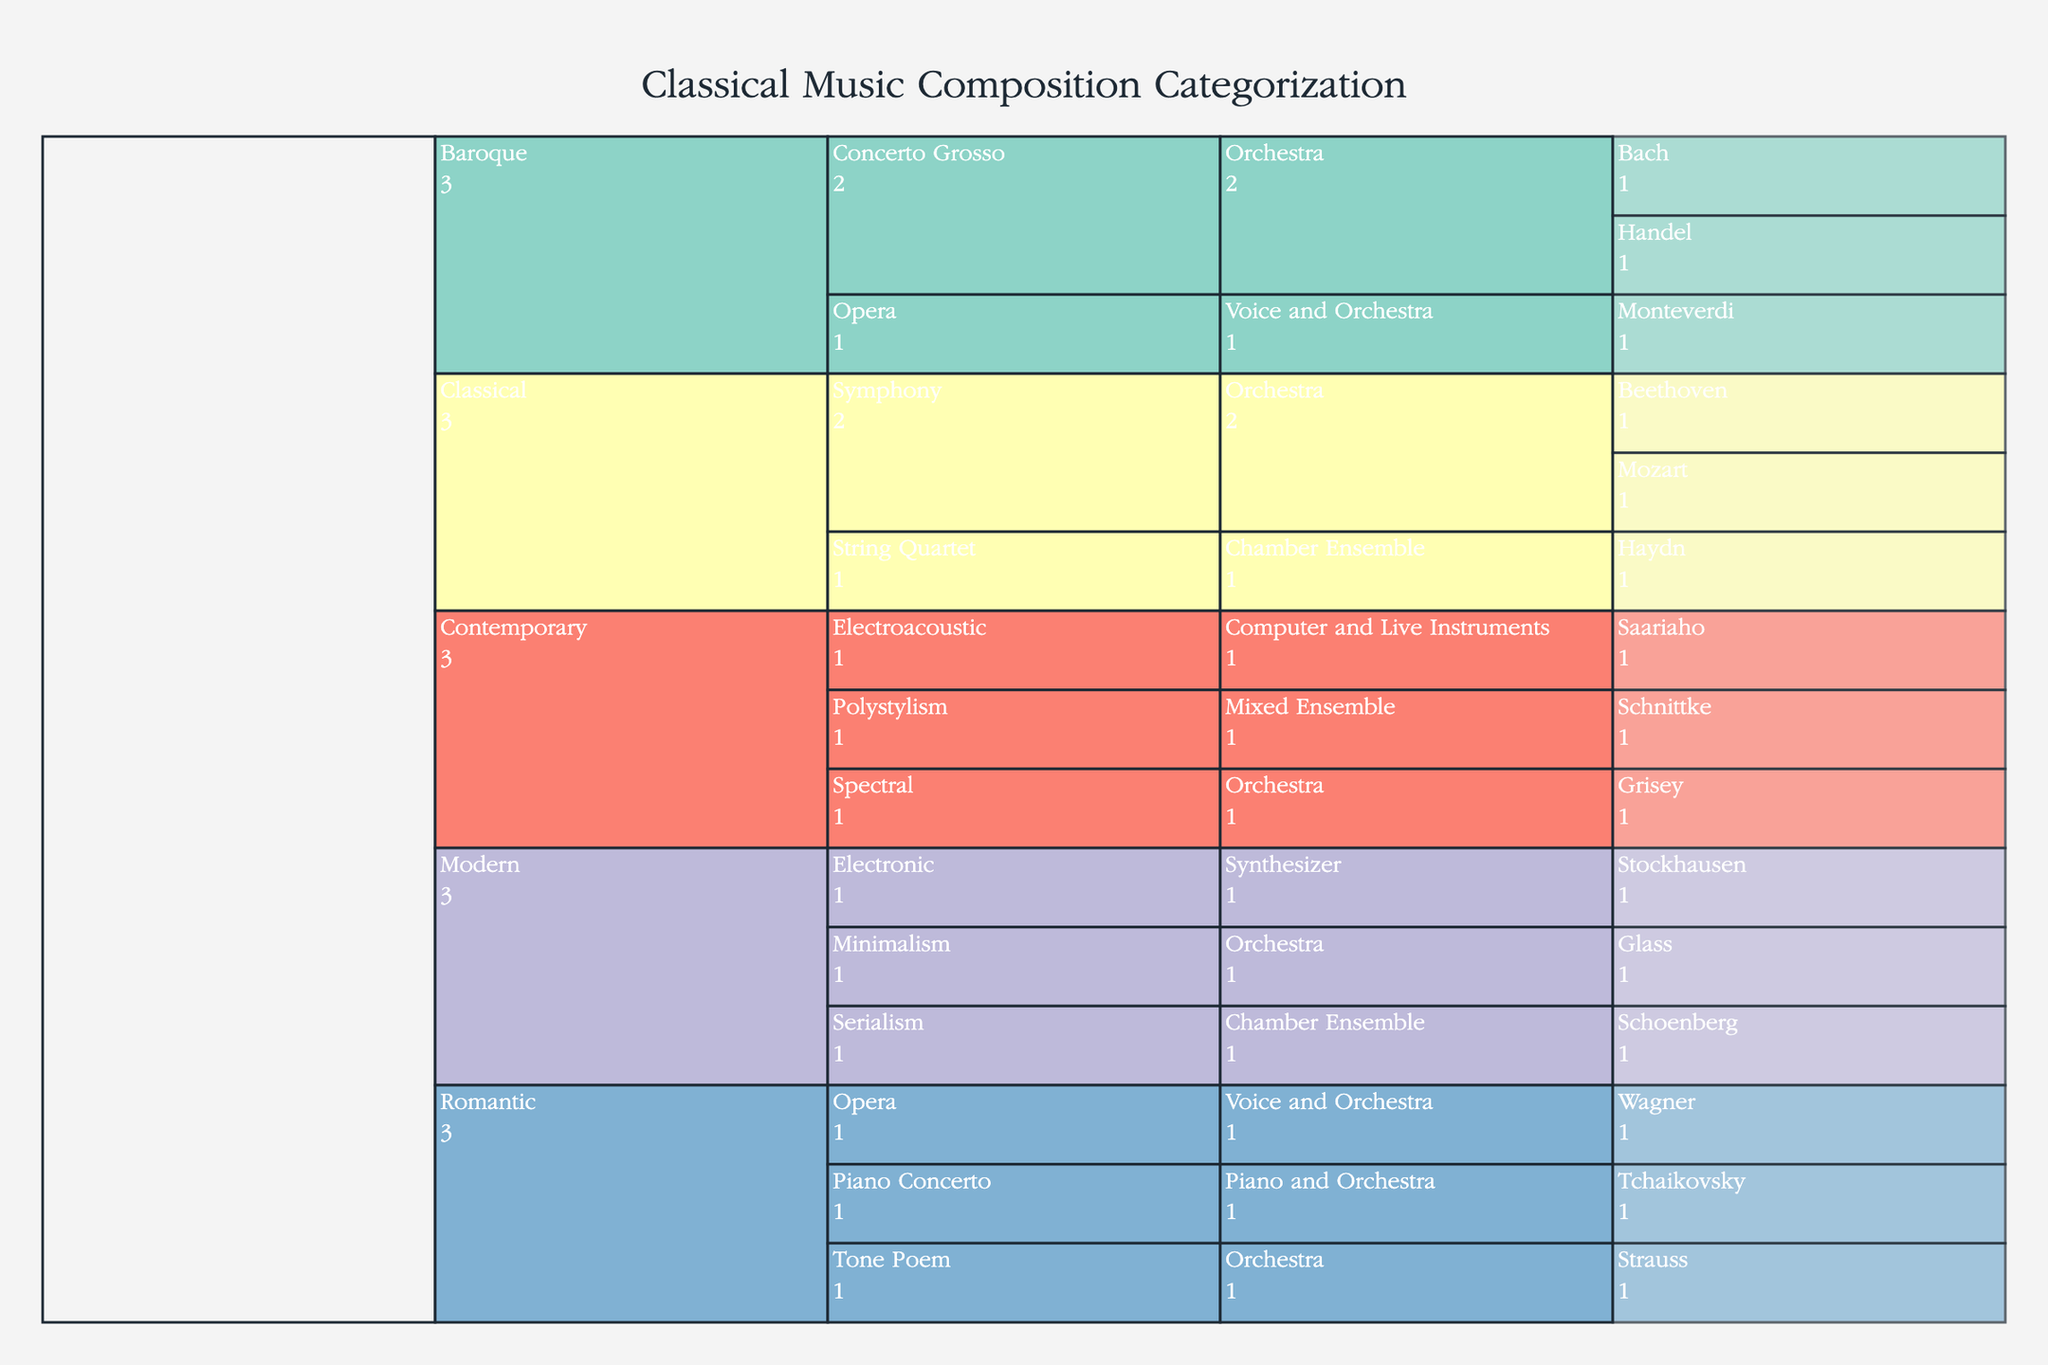what is the title of the chart? The title is usually displayed at the top of the chart, giving an overview of the entire visualized data. It helps in understanding the main subject of the chart at a glance.
Answer: "Classical Music Composition Categorization" Which era has the most unique styles represented? Look at the number of distinct styles listed under each era in the icicle chart. The era with the highest number of unique styles is the one with the most representation.
Answer: Modern How many composers are represented in the Baroque era? By navigating through the Baroque section and counting the number of individual composer names listed, one can determine the number of composers.
Answer: 3 Which era has both orchestral and electronic instrumentation? Check each era's breakdown to see which era has nodes labeled with orchestral and electronic instrumentation.
Answer: Modern How many styles are represented in the Classical era? Count the distinct styles listed under the Classical era section.
Answer: 2 Compare the number of compositions between the Romantic and Contemporary eras. Which has more? Navigate through both the Romantic and Contemporary sections and count the number of compositions in each era to compare.
Answer: Romantic Which composer is associated with the style of Polystylism? Look under the Contemporary era for the style Polystylism and see which composer's name appears.
Answer: Schnittke What's the most common instrumentation in the Romantic era? Identify and count the occurrences of each instrumentation type under the Romantic era to determine the most common one.
Answer: Orchestra What is the breakdown of composers in the Modern era by style? Navigate through the Modern era section, list each style, and note the composers associated with each style.
Answer: Schoenberg (Serialism), Glass (Minimalism), Stockhausen (Electronic) How many eras feature Opera? Scan through each era's data to count how many eras include the style labeled as Opera.
Answer: 2 